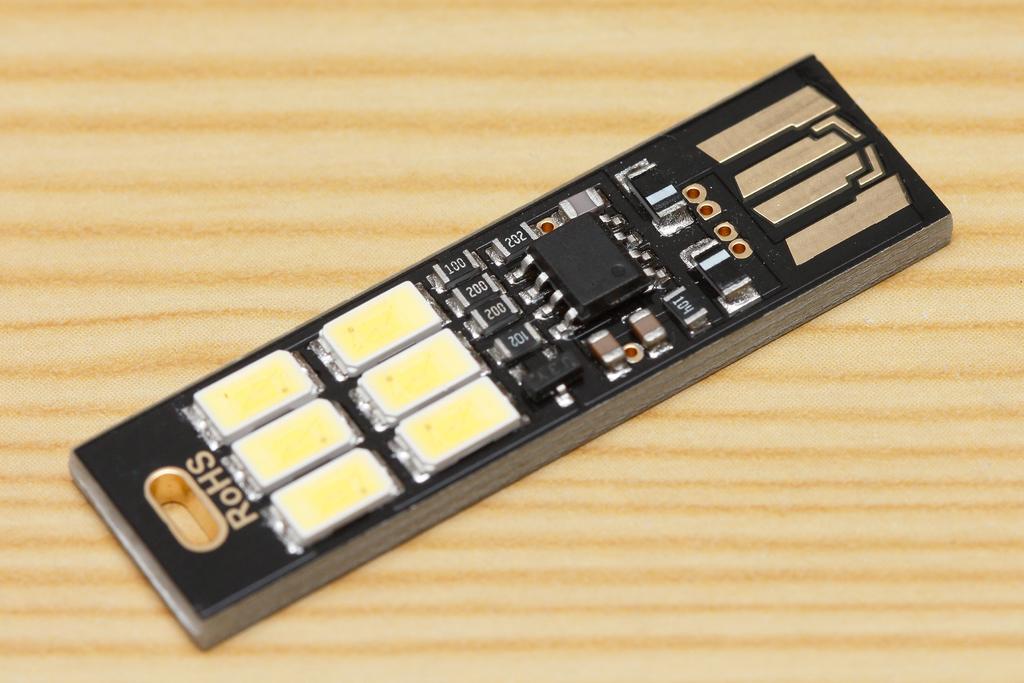What name is written in gold?
Your answer should be very brief. Rohs. 